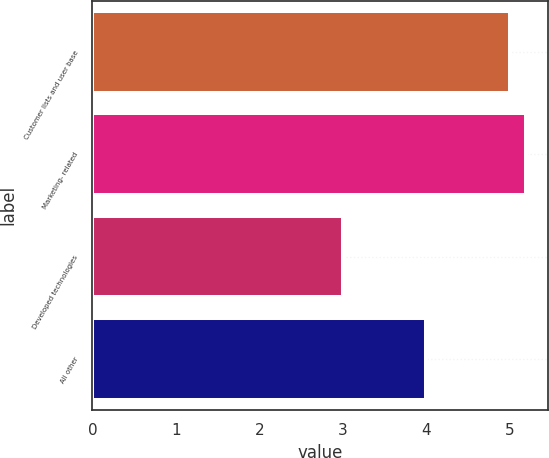Convert chart to OTSL. <chart><loc_0><loc_0><loc_500><loc_500><bar_chart><fcel>Customer lists and user base<fcel>Marketing- related<fcel>Developed technologies<fcel>All other<nl><fcel>5<fcel>5.2<fcel>3<fcel>4<nl></chart> 